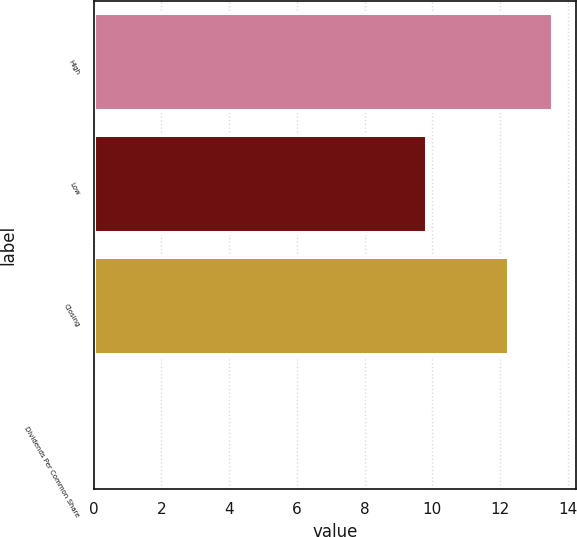Convert chart to OTSL. <chart><loc_0><loc_0><loc_500><loc_500><bar_chart><fcel>High<fcel>Low<fcel>Closing<fcel>Dividends Per Common Share<nl><fcel>13.56<fcel>9.84<fcel>12.26<fcel>0.03<nl></chart> 